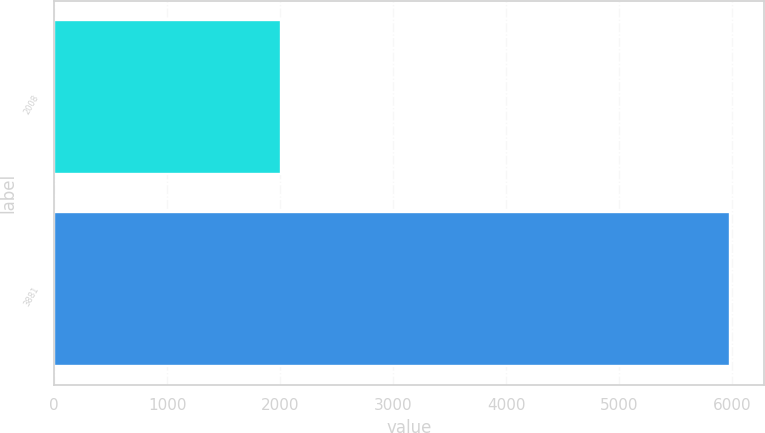<chart> <loc_0><loc_0><loc_500><loc_500><bar_chart><fcel>2008<fcel>3881<nl><fcel>2007<fcel>5982<nl></chart> 